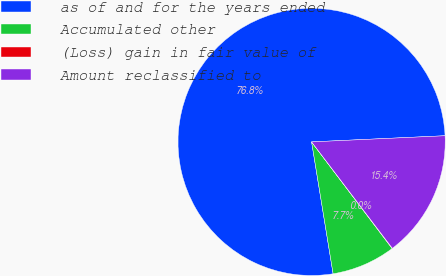Convert chart to OTSL. <chart><loc_0><loc_0><loc_500><loc_500><pie_chart><fcel>as of and for the years ended<fcel>Accumulated other<fcel>(Loss) gain in fair value of<fcel>Amount reclassified to<nl><fcel>76.84%<fcel>7.72%<fcel>0.04%<fcel>15.4%<nl></chart> 